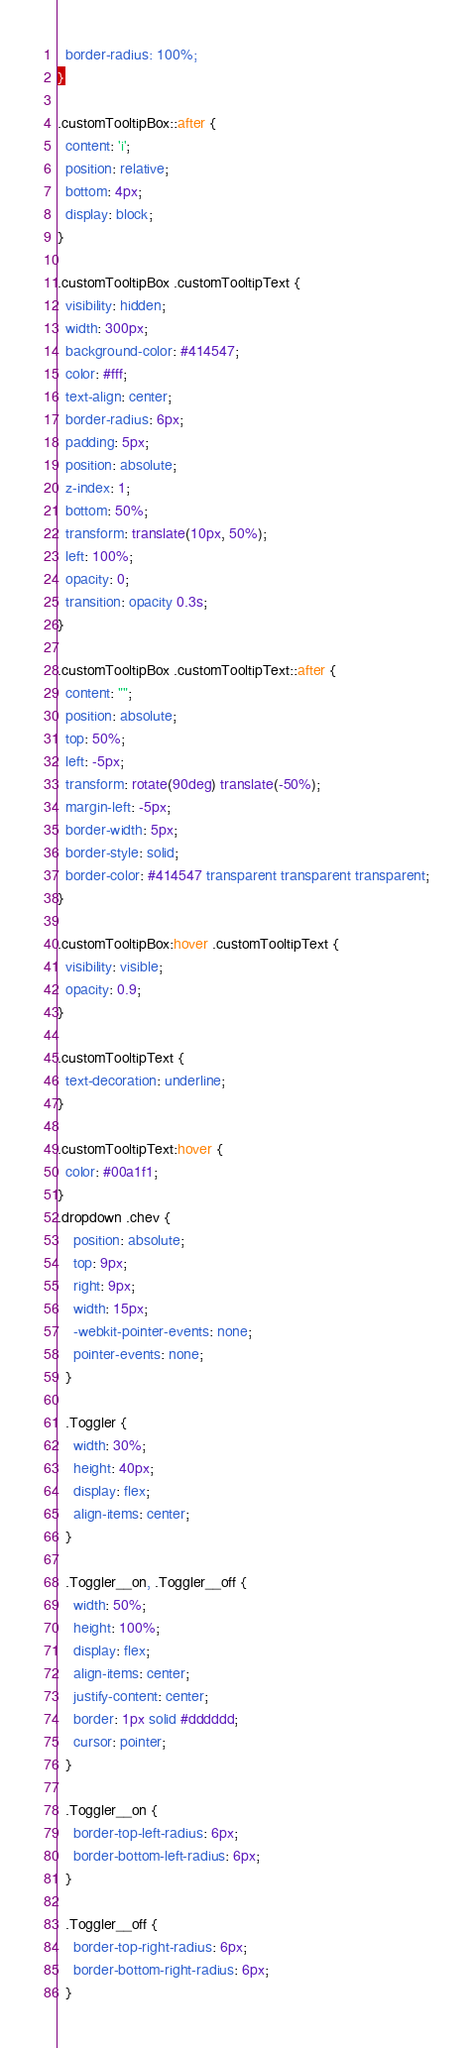Convert code to text. <code><loc_0><loc_0><loc_500><loc_500><_CSS_>  border-radius: 100%;
}

.customTooltipBox::after {
  content: 'i';
  position: relative;
  bottom: 4px;
  display: block;
}

.customTooltipBox .customTooltipText {
  visibility: hidden;
  width: 300px;
  background-color: #414547;
  color: #fff;
  text-align: center;
  border-radius: 6px;
  padding: 5px;
  position: absolute;
  z-index: 1;
  bottom: 50%;
  transform: translate(10px, 50%);
  left: 100%;
  opacity: 0;
  transition: opacity 0.3s;
}

.customTooltipBox .customTooltipText::after {
  content: "";
  position: absolute;
  top: 50%;
  left: -5px;
  transform: rotate(90deg) translate(-50%);
  margin-left: -5px;
  border-width: 5px;
  border-style: solid;
  border-color: #414547 transparent transparent transparent;
}

.customTooltipBox:hover .customTooltipText {
  visibility: visible;
  opacity: 0.9;
}

.customTooltipText {
  text-decoration: underline;
}

.customTooltipText:hover {
  color: #00a1f1;
}
.dropdown .chev {
    position: absolute;
    top: 9px;
    right: 9px;
    width: 15px;
    -webkit-pointer-events: none;
    pointer-events: none;
  }

  .Toggler {
    width: 30%;
    height: 40px;
    display: flex;
    align-items: center;
  }
  
  .Toggler__on, .Toggler__off {
    width: 50%;
    height: 100%;
    display: flex;
    align-items: center;
    justify-content: center;
    border: 1px solid #dddddd;
    cursor: pointer;
  }
  
  .Toggler__on {
    border-top-left-radius: 6px;
    border-bottom-left-radius: 6px;
  }
  
  .Toggler__off {
    border-top-right-radius: 6px;
    border-bottom-right-radius: 6px;
  }</code> 